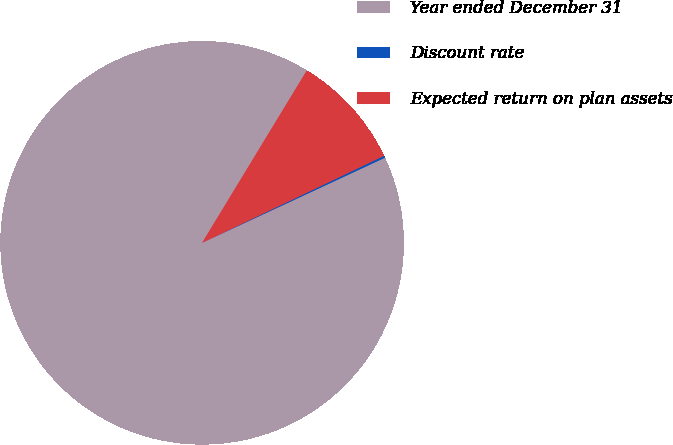<chart> <loc_0><loc_0><loc_500><loc_500><pie_chart><fcel>Year ended December 31<fcel>Discount rate<fcel>Expected return on plan assets<nl><fcel>90.62%<fcel>0.17%<fcel>9.21%<nl></chart> 